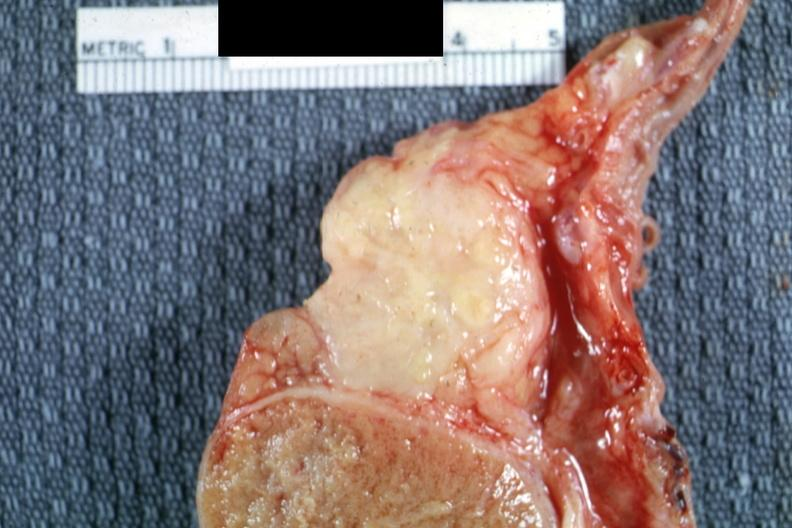s tuberculosis present?
Answer the question using a single word or phrase. Yes 